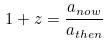<formula> <loc_0><loc_0><loc_500><loc_500>1 + z = \frac { a _ { n o w } } { a _ { t h e n } }</formula> 